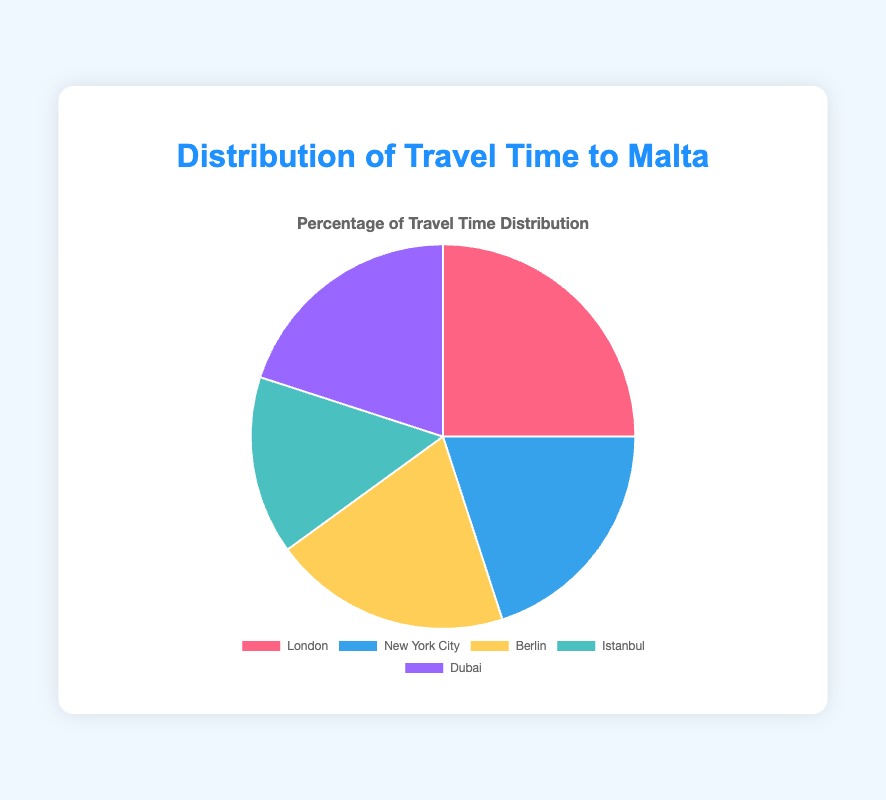What's the city with the highest percentage of travel time distribution to Malta? The city with the highest percentage is indicated by the largest slice in the pie chart. London has the largest slice, marked as 25% of travel time.
Answer: London Which cities have an equal percentage of travel time distribution to Malta? By observing the pie chart, we can see that New York City, Berlin, and Dubai each have slices representing 20% of the travel time.
Answer: New York City, Berlin, Dubai How much greater is the percentage of travel time from London compared to Istanbul? The percentage for London is 25%, and for Istanbul, it is 15%. Subtract Istanbul's percentage from London's: 25% - 15% = 10%.
Answer: 10% What is the combined percentage of travel time from the top two cities with the highest percentage distribution? The top two cities are London and New York City, with percentages of 25% and 20%, respectively. Adding these together: 25% + 20% = 45%.
Answer: 45% Which city has the shortest travel time to Malta, and what is the percentage of travel time from that city? The city with the shortest travel time has the smallest percentage slice and the least number of hours. Istanbul shows a percentage of 15%, which is paired with the shortest travel time.
Answer: Istanbul, 15% What are the colors used to represent each city in the pie chart? By referring to the chart, each city has a specific color: London is red, New York City is blue, Berlin is yellow, Istanbul is teal, and Dubai is purple.
Answer: London: red, New York City: blue, Berlin: yellow, Istanbul: teal, Dubai: purple What percentage of the travel time distribution comes from cities with more than 3 hours of travel time to Malta? The cities with travel times more than 3 hours are London (3.15 hours) and New York City (10.5 hours). Summing up their percentages: 25% (London) + 20% (New York City) = 45%.
Answer: 45% If the travel time from Berlin doubled, would its percentage slice be the largest? Doubling Berlin's time (2.45 hours) yields 4.9 hours. Compared to the highest current travel time (10.5 hours from New York City), 4.9 hours would still not be the largest. Therefore, its percentage slice would not be the largest.
Answer: No What's the average travel time to Malta from all the listed cities? Sum up the travel times: 3.15 (London) + 10.5 (New York City) + 2.45 (Berlin) + 2.4 (Istanbul) + 6.5 (Dubai) = 24.95 hours. Divide by the number of cities (5): 24.95 / 5 ≈ 4.99 hours.
Answer: 4.99 hours 